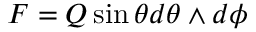<formula> <loc_0><loc_0><loc_500><loc_500>F = Q \sin \theta d \theta \wedge d \phi</formula> 